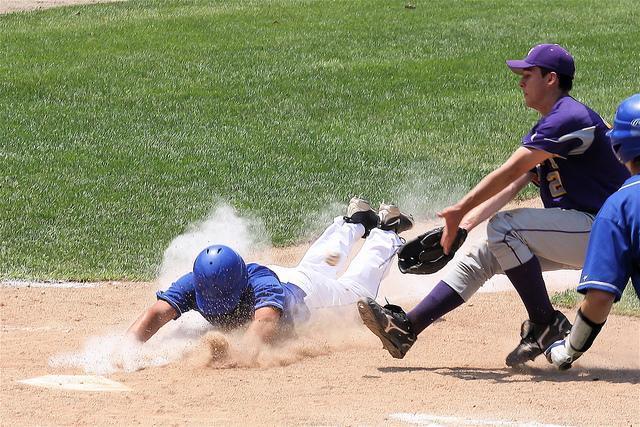How many players are on the ground?
Give a very brief answer. 1. How many people can be seen?
Give a very brief answer. 3. 